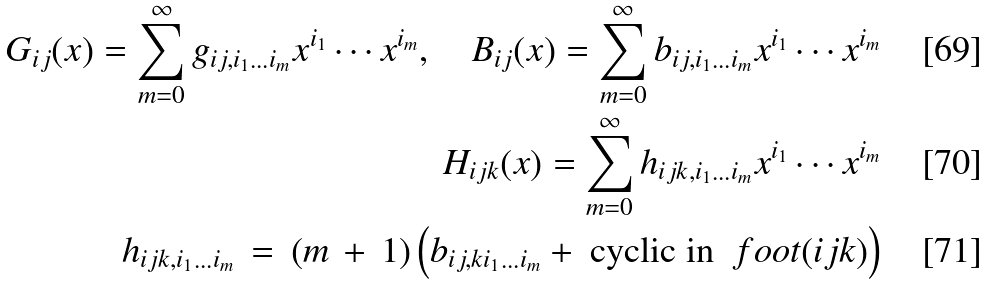Convert formula to latex. <formula><loc_0><loc_0><loc_500><loc_500>G _ { i j } ( x ) = \sum _ { m = 0 } ^ { \infty } g _ { i j , i _ { 1 } \dots i _ { m } } x ^ { i _ { 1 } } \cdots x ^ { i _ { m } } , \quad B _ { i j } ( x ) = \sum _ { m = 0 } ^ { \infty } b _ { i j , i _ { 1 } \dots i _ { m } } x ^ { i _ { 1 } } \cdots x ^ { i _ { m } } \\ H _ { i j k } ( x ) = \sum _ { m = 0 } ^ { \infty } h _ { i j k , i _ { 1 } \dots i _ { m } } x ^ { i _ { 1 } } \cdots x ^ { i _ { m } } \\ h _ { i j k , i _ { 1 } \dots i _ { m } } \, = \, ( m \, + \, 1 ) \left ( b _ { i j , k i _ { 1 } \dots i _ { m } } + \text { cyclic in } \ f o o t { ( i j k ) } \right )</formula> 